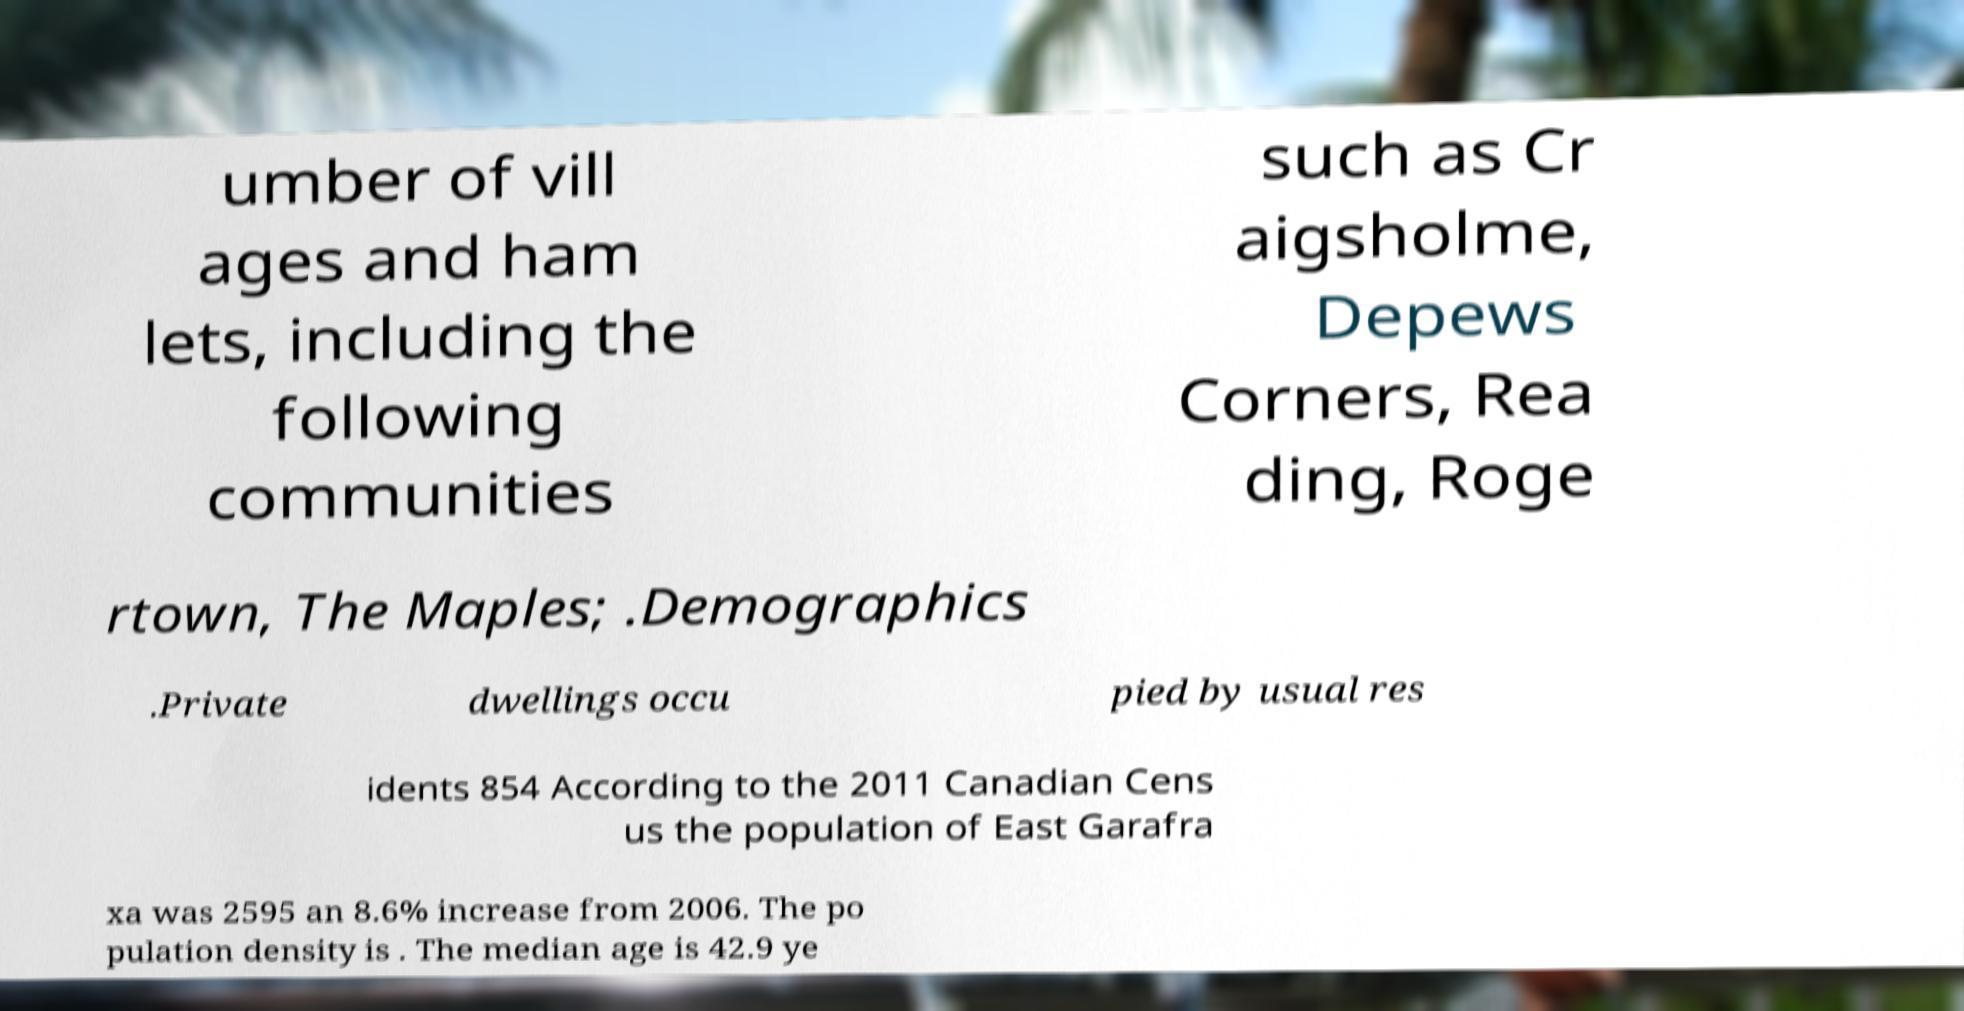Please read and relay the text visible in this image. What does it say? umber of vill ages and ham lets, including the following communities such as Cr aigsholme, Depews Corners, Rea ding, Roge rtown, The Maples; .Demographics .Private dwellings occu pied by usual res idents 854 According to the 2011 Canadian Cens us the population of East Garafra xa was 2595 an 8.6% increase from 2006. The po pulation density is . The median age is 42.9 ye 